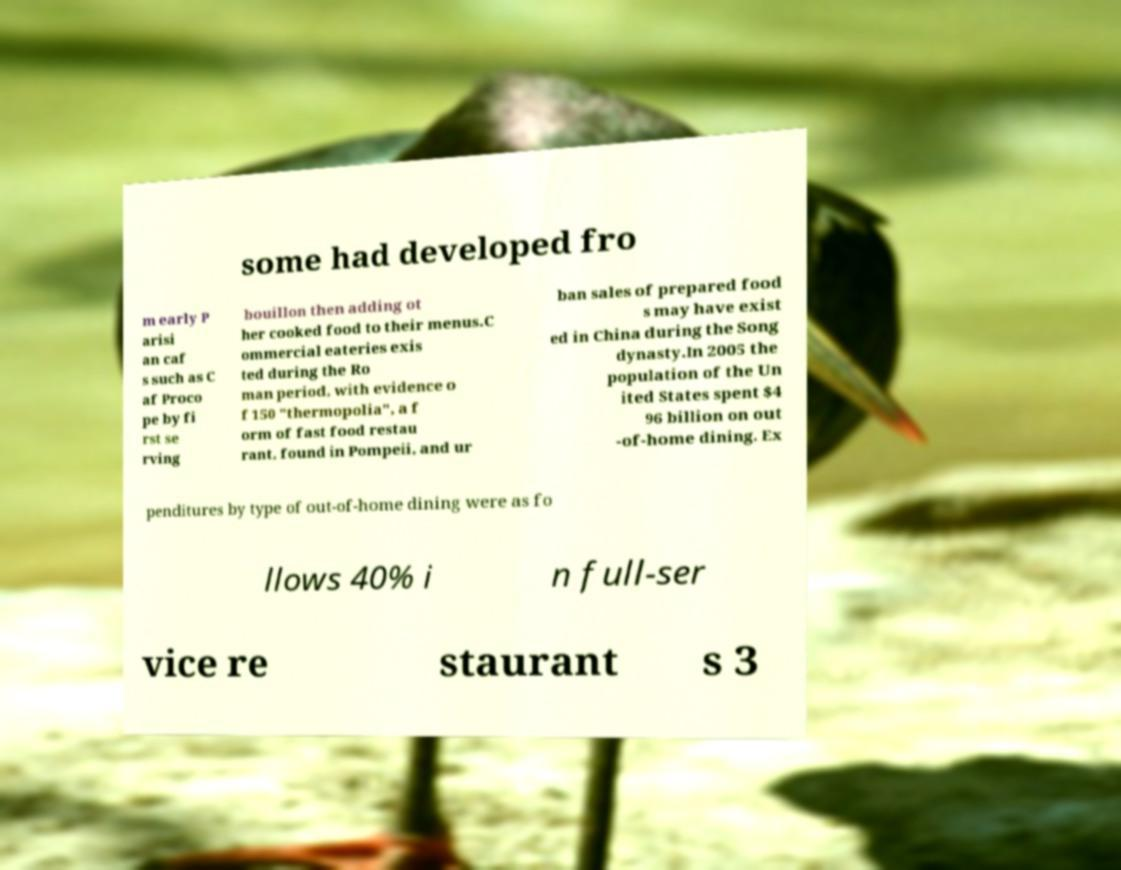What messages or text are displayed in this image? I need them in a readable, typed format. some had developed fro m early P arisi an caf s such as C af Proco pe by fi rst se rving bouillon then adding ot her cooked food to their menus.C ommercial eateries exis ted during the Ro man period, with evidence o f 150 "thermopolia", a f orm of fast food restau rant, found in Pompeii, and ur ban sales of prepared food s may have exist ed in China during the Song dynasty.In 2005 the population of the Un ited States spent $4 96 billion on out -of-home dining. Ex penditures by type of out-of-home dining were as fo llows 40% i n full-ser vice re staurant s 3 